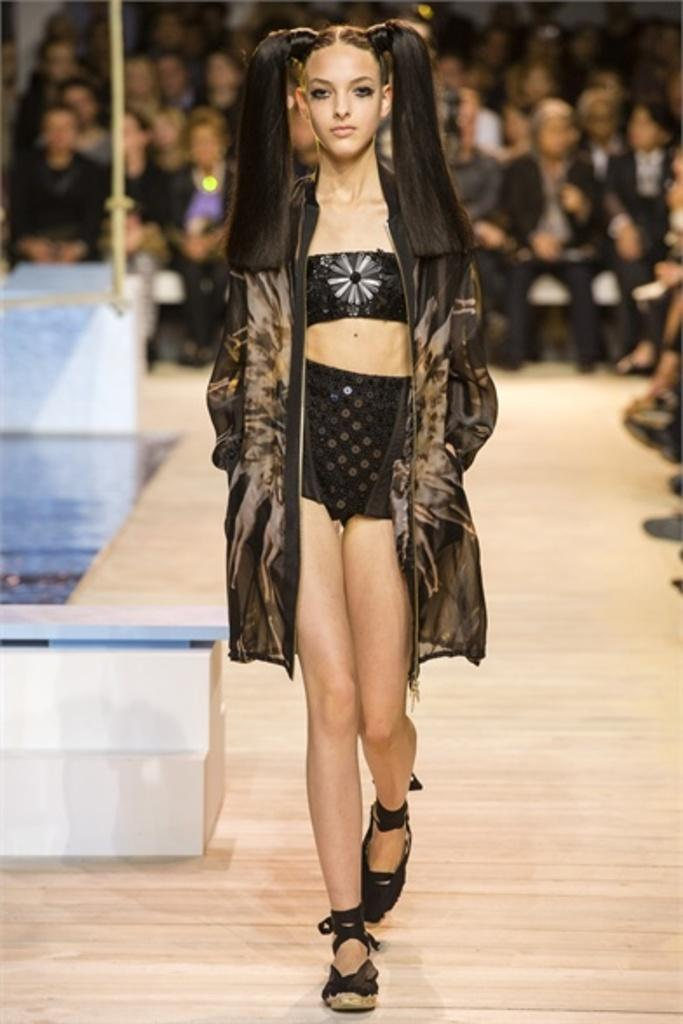What is the main subject of the image? The main subject of the image is a woman. What is the woman doing in the image? The woman is walking on the floor. Can you describe the background of the image? There are people visible in the background of the image. What type of pickle is the woman holding in the image? There is no pickle present in the image; the woman is simply walking on the floor. Is the woman adding salt to her food in the image? There is no indication of food or the addition of salt in the image. 